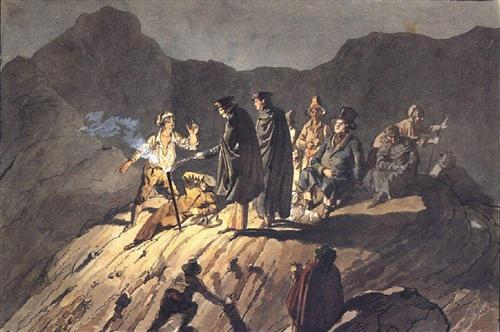If you could add an element to this scene, what would it be and why? I would add a stormy sky with lightning bolts in the background. This addition would heighten the drama, reflecting the intensity of the confrontation. The lightning could illuminate the figures in brief, stark flashes, emphasizing their expressions and actions. It would also add an element of nature's fury, aligning with the Romantic era's fascination with the sublime and powerful forces. 